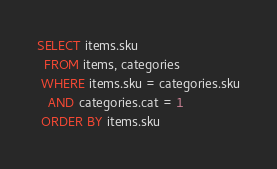Convert code to text. <code><loc_0><loc_0><loc_500><loc_500><_SQL_>SELECT items.sku 
  FROM items, categories
 WHERE items.sku = categories.sku
   AND categories.cat = 1
 ORDER BY items.sku</code> 